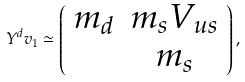Convert formula to latex. <formula><loc_0><loc_0><loc_500><loc_500>Y ^ { d } v _ { 1 } \simeq \left ( \begin{array} { c c } m _ { d } & m _ { s } V _ { u s } \\ & m _ { s } \end{array} \right ) ,</formula> 